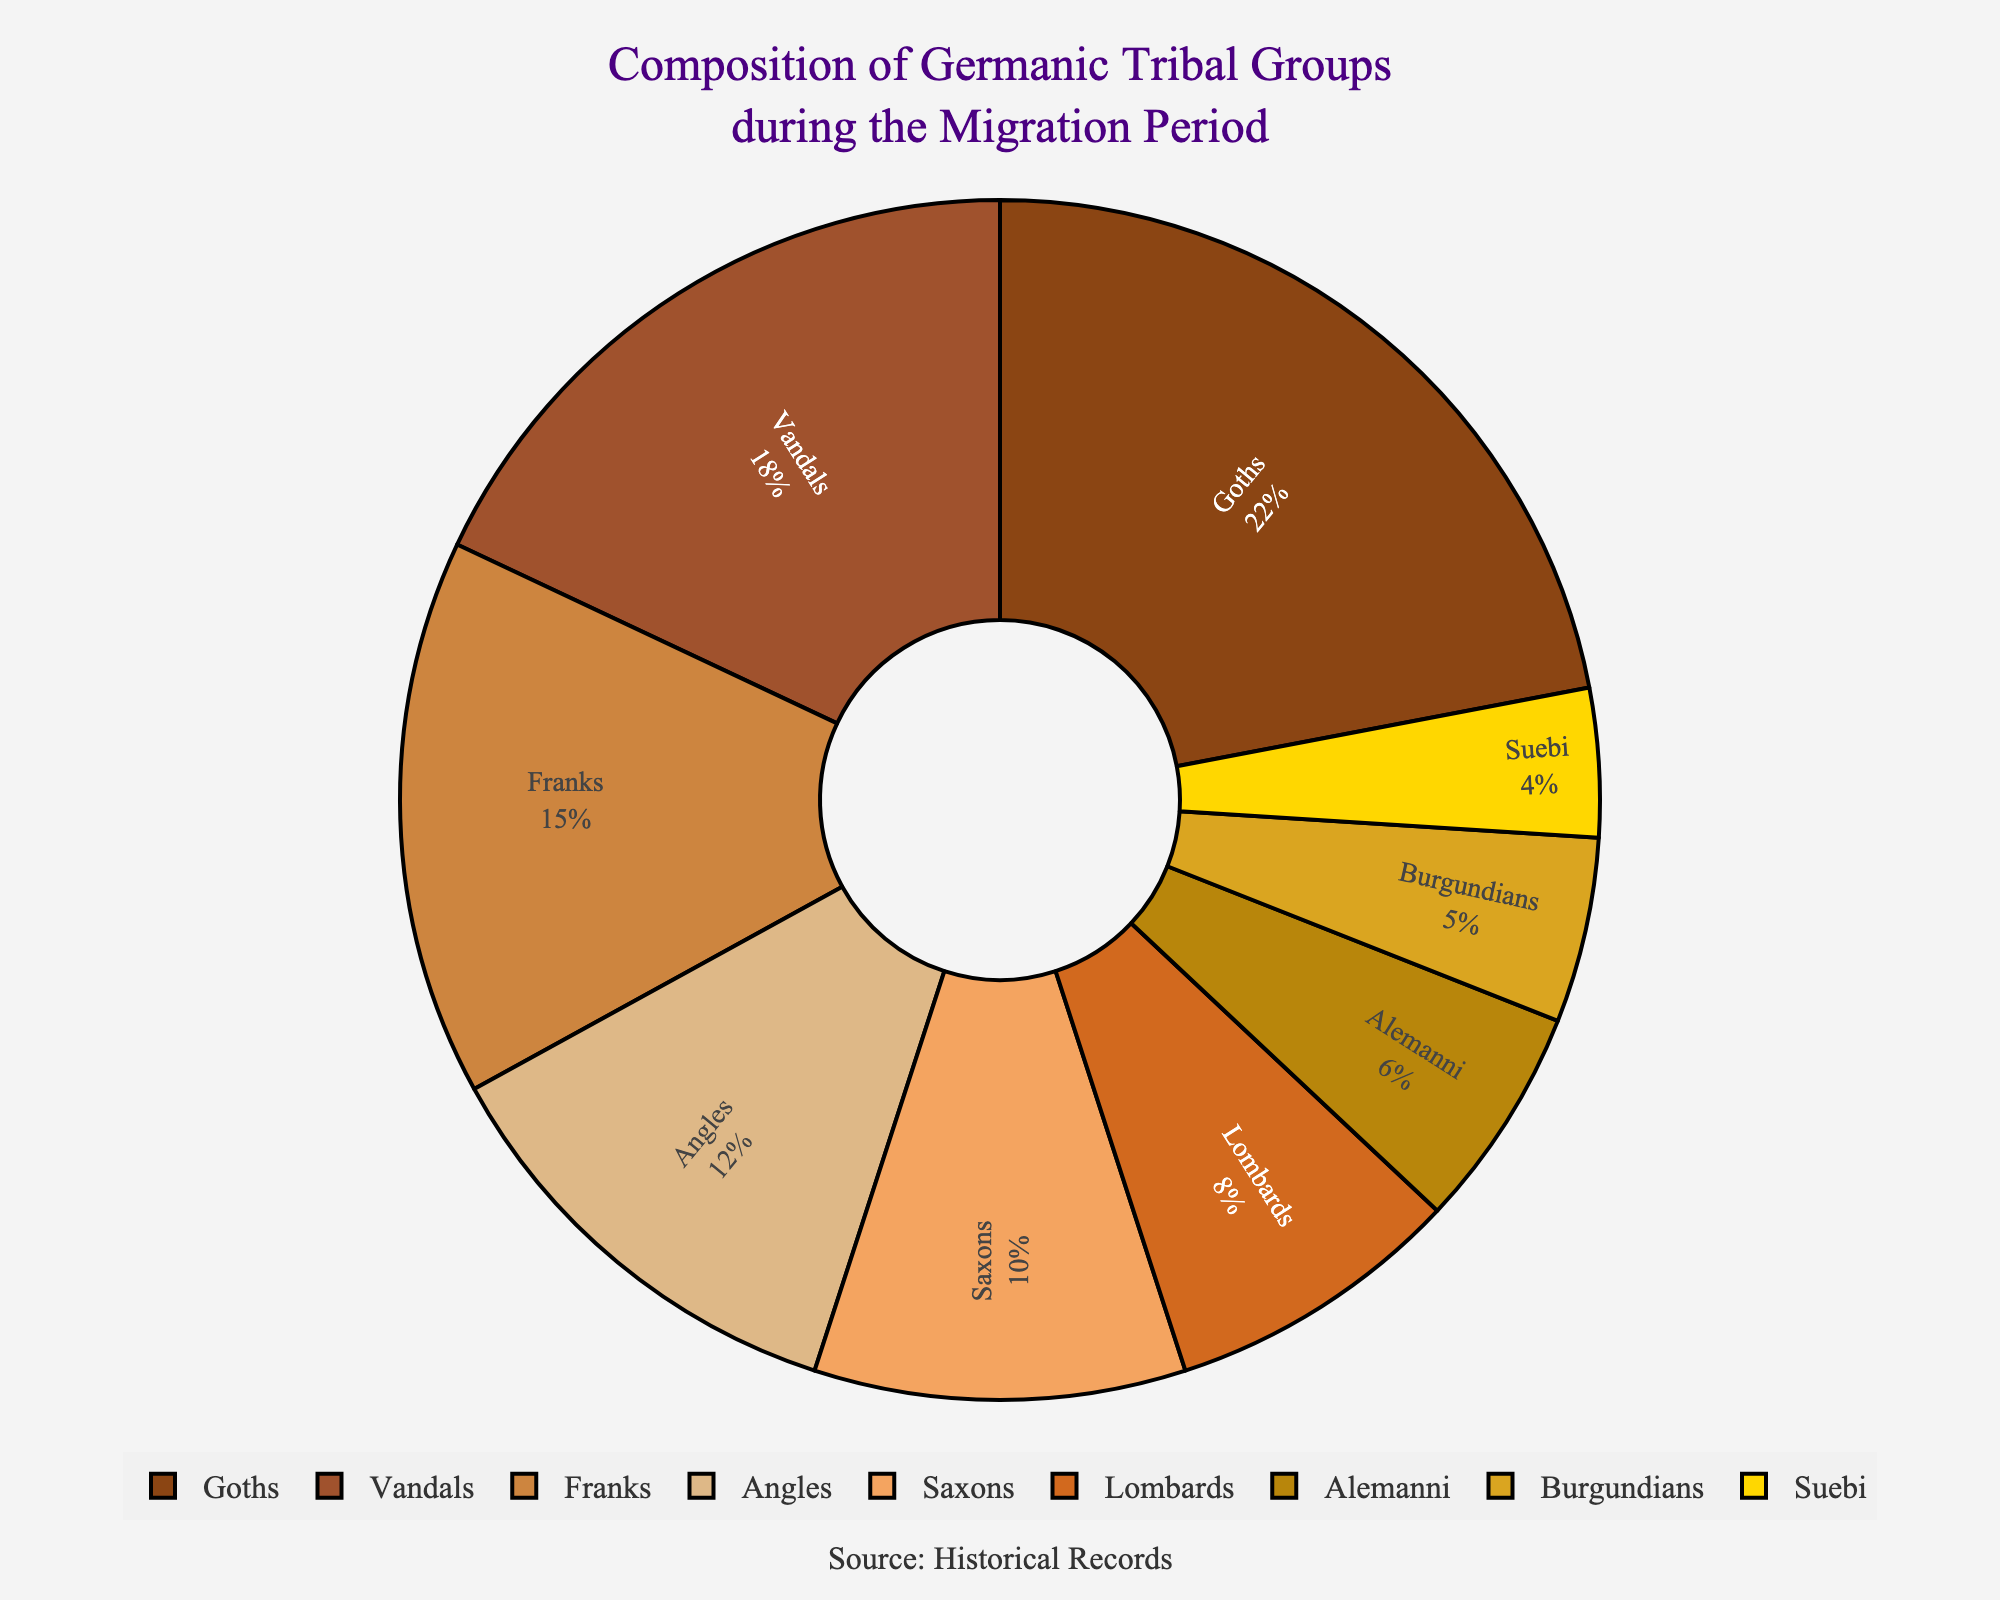What's the percentage contribution of Goths and Vandals combined? We need to find the sum of the percentages for Goths and Vandals. From the figure, Goths contribute 22% and Vandals contribute 18%. Therefore, 22% + 18% = 40%.
Answer: 40% Which tribe has the smallest percentage in the composition? We look for the tribe with the smallest percentage in the figure, which is Suebi at 4%.
Answer: Suebi How do the percentages of Franks and Angles compare? By comparing their respective percentages, we see that Franks have 15% and Angles have 12%. Franks have a greater percentage than Angles.
Answer: Franks > Angles Which color represents the Saxons? By referring to the visual attributes, Saxons are represented by the fifth color from the list: #F4A460, which is sandy brown.
Answer: Sandy Brown What is the difference in percentage between the Alemanni and Burgundians? The percentage for Alemanni is 6% and for Burgundians is 5%. Subtracting these gives 6% - 5% = 1%.
Answer: 1% If we combine the percentages of Angles, Saxons, and Lombards, what is the total? Adding their percentages: Angles (12%) + Saxons (10%) + Lombards (8%) equals 12% + 10% + 8% = 30%.
Answer: 30% Between Goths and Vandals, which tribe has a higher percentage, and by how much? Goths have 22% and Vandals have 18%. Goths have 4% more than Vandals.
Answer: Goths by 4% What percentage is represented by tribes that each contribute less than 10%? The tribes with less than 10% are Lombards (8%), Alemanni (6%), Burgundians (5%), and Suebi (4%). Adding these percentages: 8% + 6% + 5% + 4% = 23%.
Answer: 23% Identify the tribe associated with the yellow color segment. The yellow color represents the tribe with the smallest percentage, which from the figure is Suebi at 4%.
Answer: Suebi What's the combined percentage of the five smallest contributing tribes? The five smallest tribes are: Lombards (8%), Alemanni (6%), Burgundians (5%), and Suebi (4%) which totals 8% + 6% + 5% + 4% = 23%.
Answer: 23% 